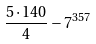Convert formula to latex. <formula><loc_0><loc_0><loc_500><loc_500>\frac { 5 \cdot 1 4 0 } { 4 } - 7 ^ { 3 5 7 }</formula> 